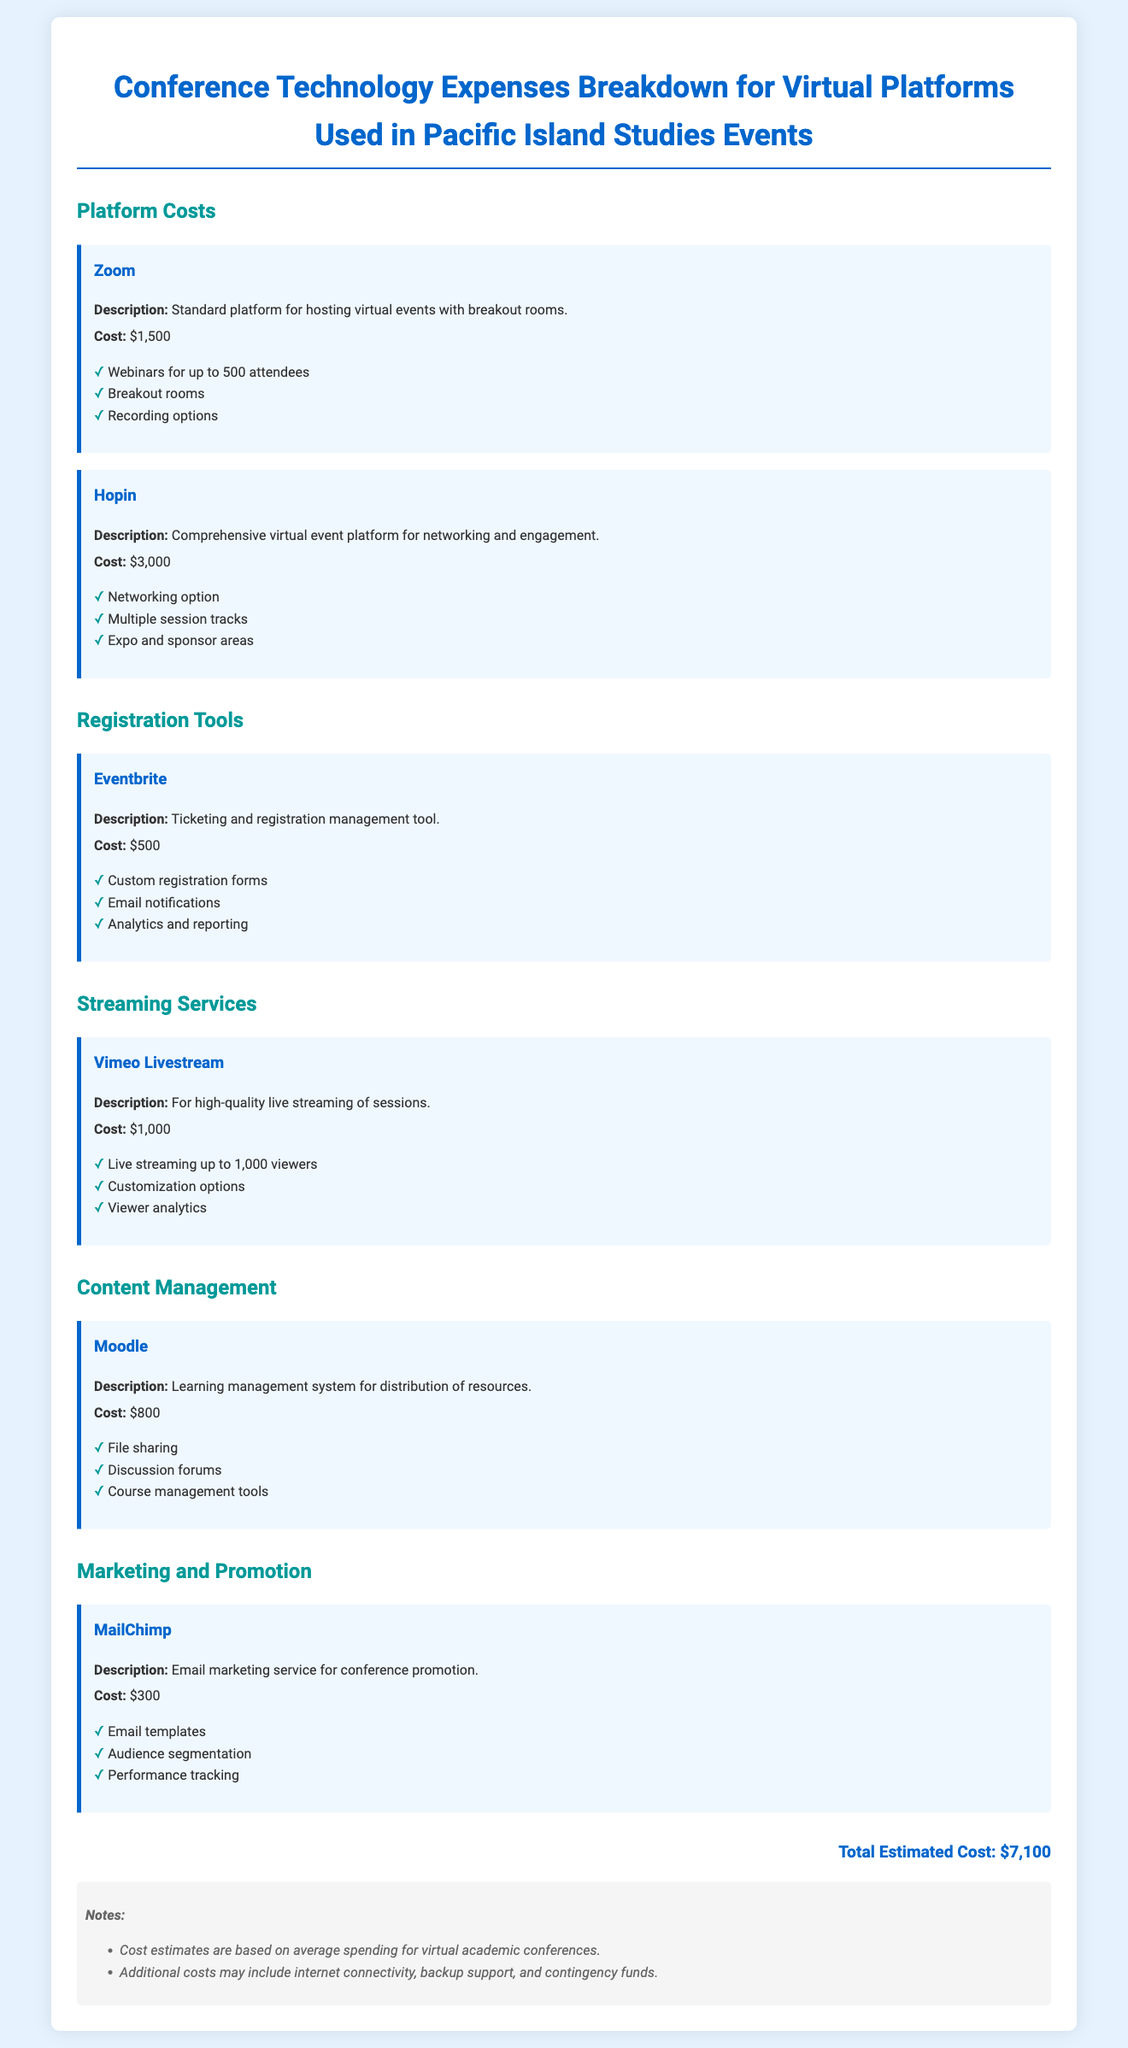What is the total estimated cost? The total estimated cost is clearly stated at the end of the document.
Answer: $7,100 What is the cost of Zoom? The cost of Zoom is listed under platform costs in the document.
Answer: $1,500 What features does Hopin provide? The document lists features provided by Hopin as part of the expense item.
Answer: Networking option, Multiple session tracks, Expo and sponsor areas What is the purpose of Eventbrite? The document offers a brief description of the role of Eventbrite in the conference setup.
Answer: Ticketing and registration management tool Which streaming service is used for live sessions? The document identifies Vimeo Livestream as the service for high-quality live streaming.
Answer: Vimeo Livestream How much does MailChimp cost? The document specifies the cost of MailChimp under the marketing and promotion section.
Answer: $300 What platform is used for content management? The document names the learning management system included in the expenses.
Answer: Moodle What additional costs might be incurred? The notes section of the document mentions extra potential expenses outside of listed costs.
Answer: Internet connectivity, backup support, and contingency funds 